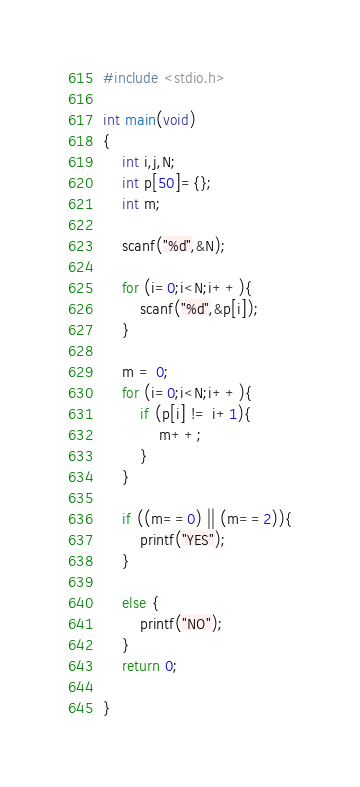<code> <loc_0><loc_0><loc_500><loc_500><_C_>#include <stdio.h>

int main(void)
{
	int i,j,N;
	int p[50]={};
	int m;

	scanf("%d",&N);

	for (i=0;i<N;i++){
		scanf("%d",&p[i]);
	}

	m = 0;
	for (i=0;i<N;i++){
		if (p[i] != i+1){
			m++;
		}
	}
	
	if ((m==0) || (m==2)){
		printf("YES");
	}

	else {
		printf("NO");
	}
	return 0;	
	
}</code> 